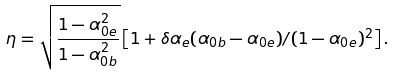<formula> <loc_0><loc_0><loc_500><loc_500>\eta = \sqrt { \frac { 1 - \alpha _ { 0 e } ^ { 2 } } { 1 - \alpha _ { 0 b } ^ { 2 } } } \left [ 1 + \delta \alpha _ { e } ( \alpha _ { 0 b } - \alpha _ { 0 e } ) / ( 1 - \alpha _ { 0 e } ) ^ { 2 } \right ] .</formula> 